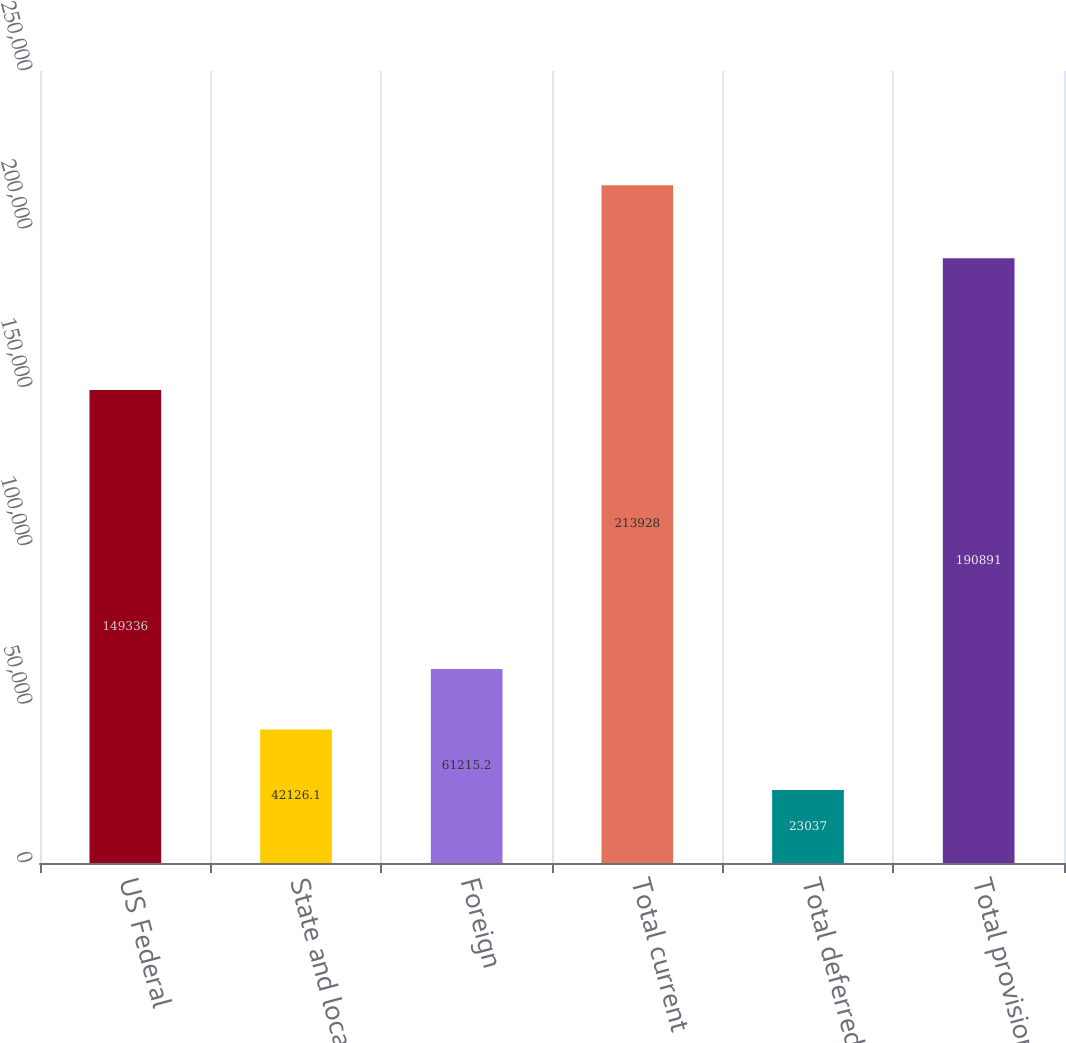Convert chart. <chart><loc_0><loc_0><loc_500><loc_500><bar_chart><fcel>US Federal<fcel>State and local<fcel>Foreign<fcel>Total current<fcel>Total deferred<fcel>Total provision<nl><fcel>149336<fcel>42126.1<fcel>61215.2<fcel>213928<fcel>23037<fcel>190891<nl></chart> 